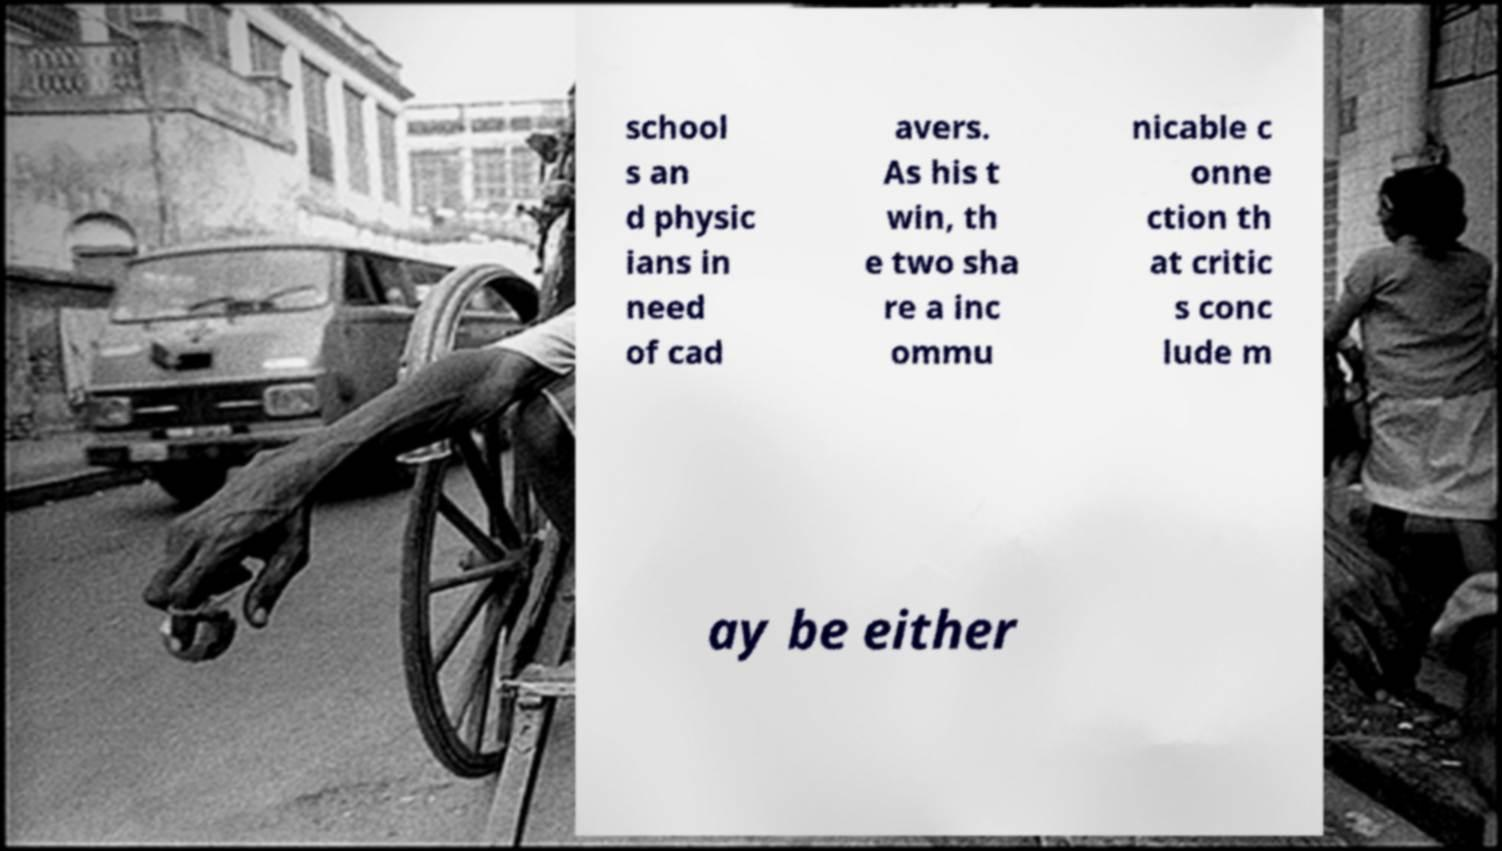Can you accurately transcribe the text from the provided image for me? school s an d physic ians in need of cad avers. As his t win, th e two sha re a inc ommu nicable c onne ction th at critic s conc lude m ay be either 